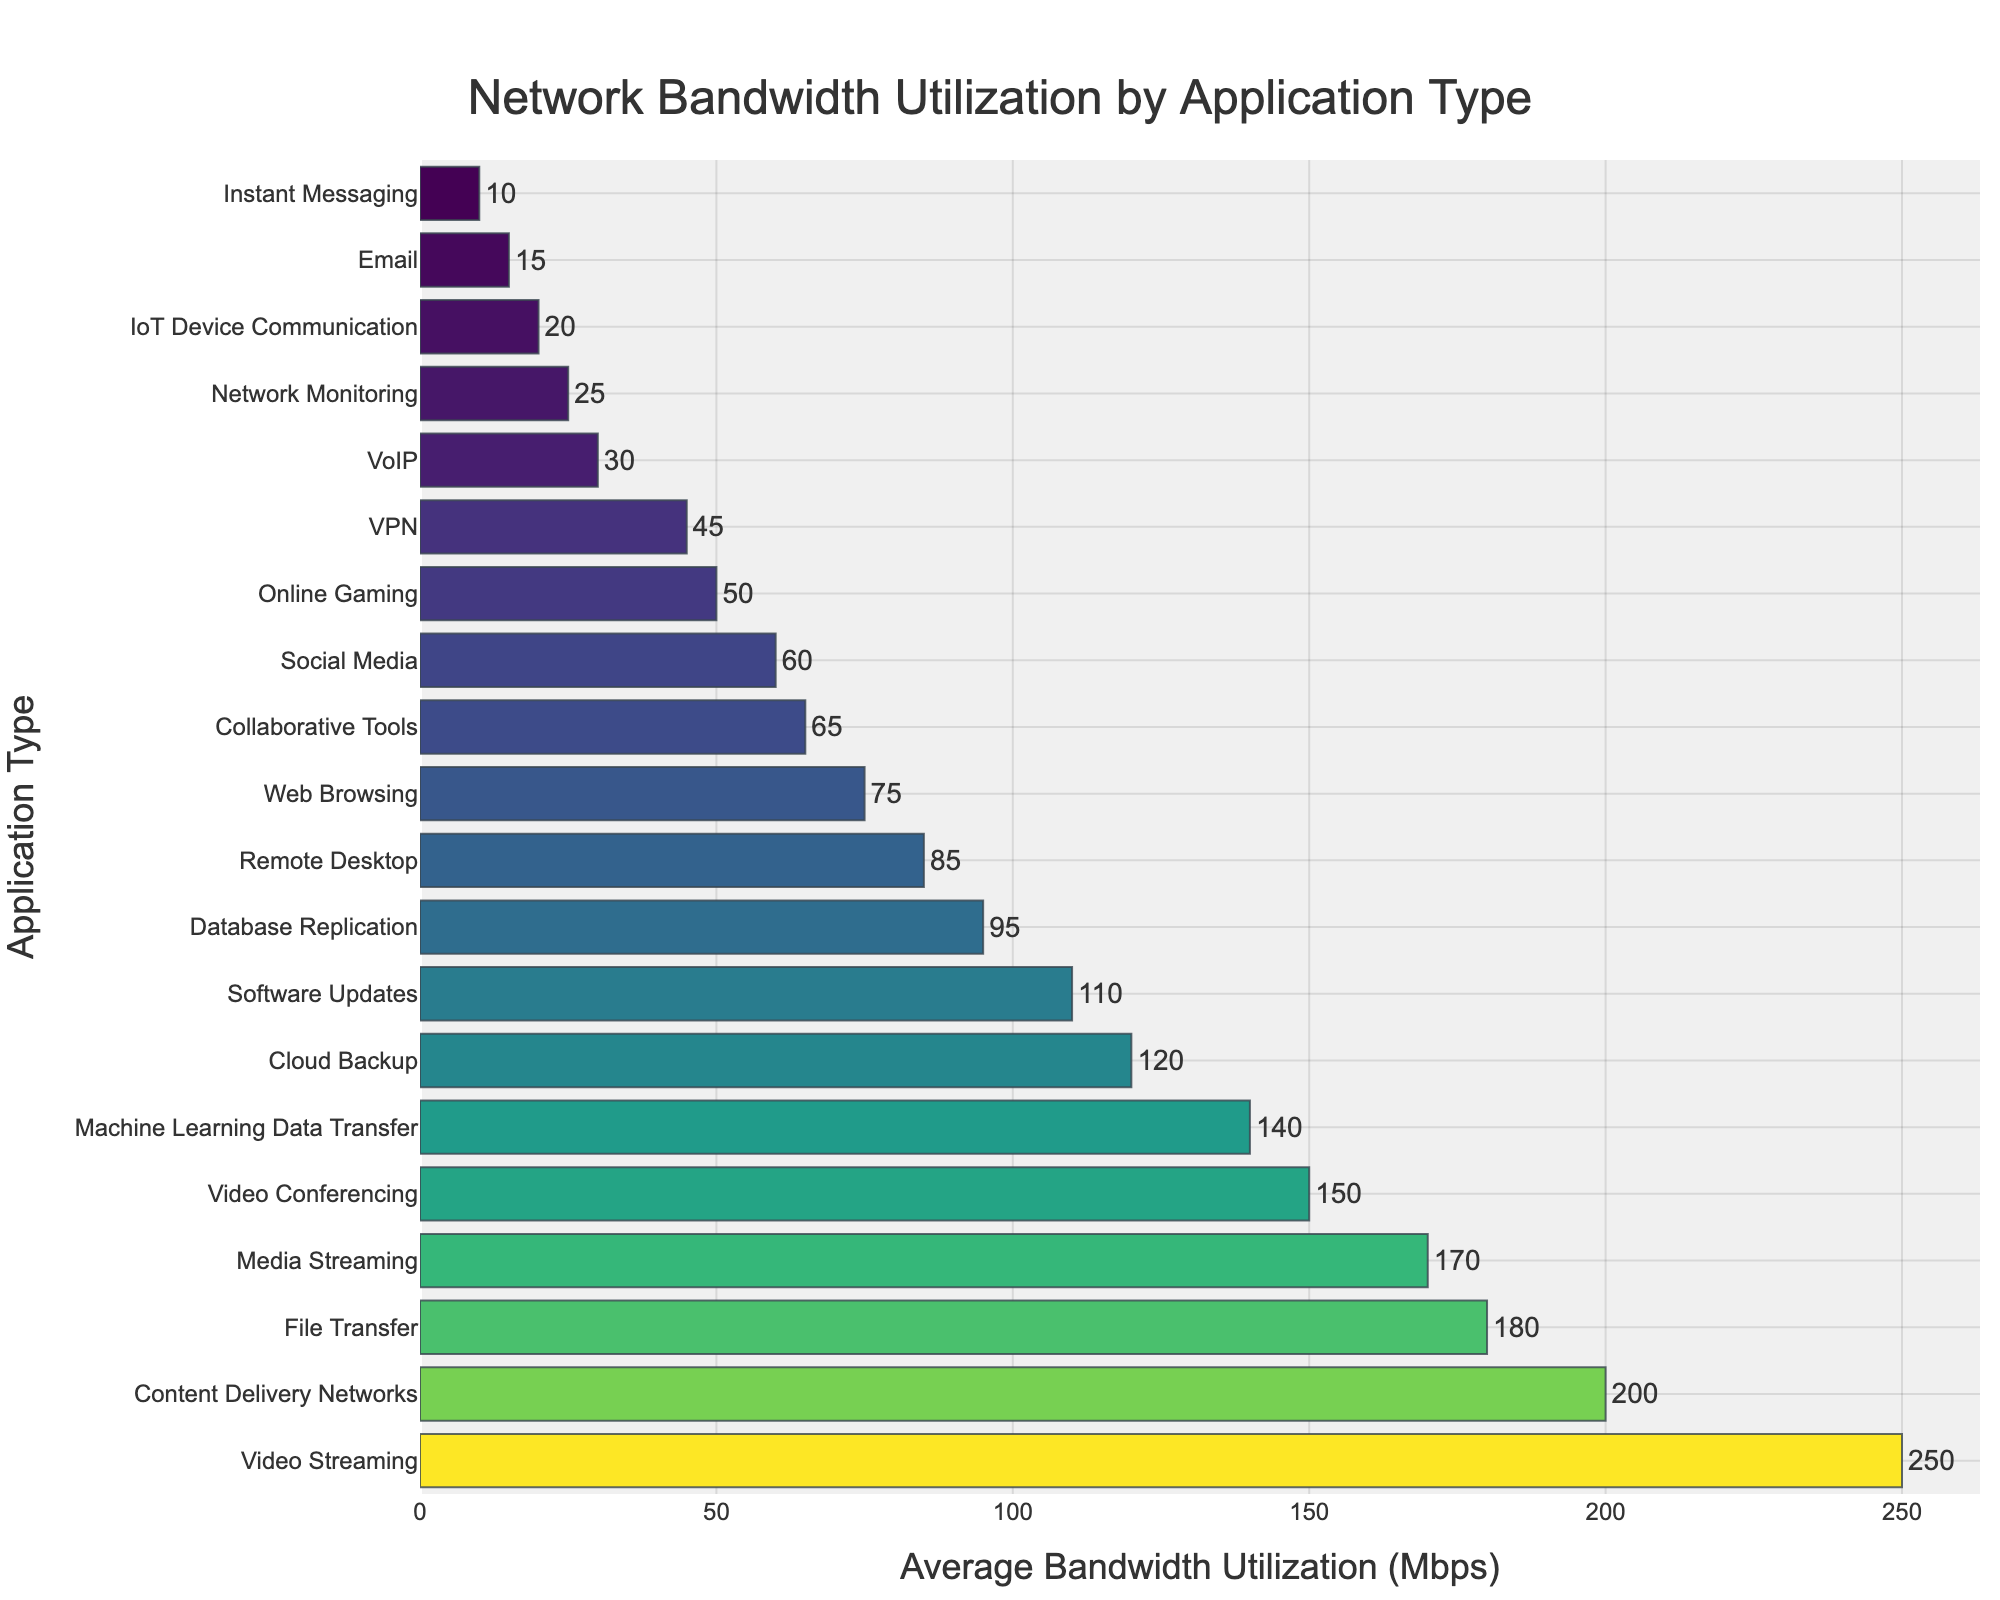Which application type uses the most bandwidth? The application type with the highest average bandwidth utilization (the longest bar in the bar chart) is Video Streaming with 250 Mbps.
Answer: Video Streaming Which application type has the lowest bandwidth utilization? The longest bars indicate the highest bandwidth utilization. The shortest bar, representing the lowest bandwidth utilization, belongs to Instant Messaging with 10 Mbps.
Answer: Instant Messaging How much more bandwidth does Video Streaming use than Email? Video Streaming uses 250 Mbps, while Email uses 15 Mbps. The difference in utilization is 250 - 15 = 235 Mbps.
Answer: 235 Mbps Arrange the application types with bandwidth usage between 50 and 100 Mbps in ascending order. The relevant applications and their utilizations are: Online Gaming (50), Collaborative Tools (65), Remote Desktop (85), and Database Replication (95). In ascending order: Online Gaming, Collaborative Tools, Remote Desktop, Database Replication.
Answer: Online Gaming, Collaborative Tools, Remote Desktop, Database Replication What is the total bandwidth utilization of Cloud Backup, Media Streaming, and VoIP combined? Cloud Backup uses 120 Mbps, Media Streaming uses 170 Mbps, and VoIP uses 30 Mbps. Summing these values gives 120 + 170 + 30 = 320 Mbps.
Answer: 320 Mbps Compare the bandwidth utilization of Content Delivery Networks and Video Conferencing. Content Delivery Networks use 200 Mbps, while Video Conferencing uses 150 Mbps. Content Delivery Networks use 50 Mbps more bandwidth than Video Conferencing.
Answer: Content Delivery Networks Which applications have a bandwidth utilization greater than 150 Mbps? The applications with bandwidth utilization above 150 Mbps are Video Streaming (250 Mbps), Media Streaming (170 Mbps), and Content Delivery Networks (200 Mbps).
Answer: Video Streaming, Media Streaming, Content Delivery Networks How does the bandwidth utilization of Database Replication compare to File Transfer? Database Replication uses 95 Mbps, and File Transfer uses 180 Mbps. Thus, Database Replication uses 85 Mbps less than File Transfer.
Answer: File Transfer uses more What is the average bandwidth utilization of Web Browsing, Email, VoIP, and Social Media? The utilizations are Web Browsing (75 Mbps), Email (15 Mbps), VoIP (30 Mbps), and Social Media (60 Mbps). The average is calculated as (75 + 15 + 30 + 60) / 4 = 45 Mbps.
Answer: 45 Mbps 